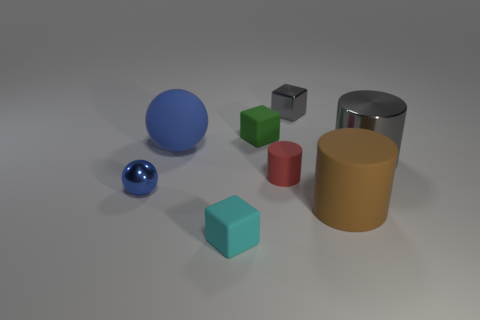Add 2 big red metallic cylinders. How many objects exist? 10 Subtract all balls. How many objects are left? 6 Subtract all tiny gray objects. Subtract all big things. How many objects are left? 4 Add 6 small cyan cubes. How many small cyan cubes are left? 7 Add 6 large blocks. How many large blocks exist? 6 Subtract 1 red cylinders. How many objects are left? 7 